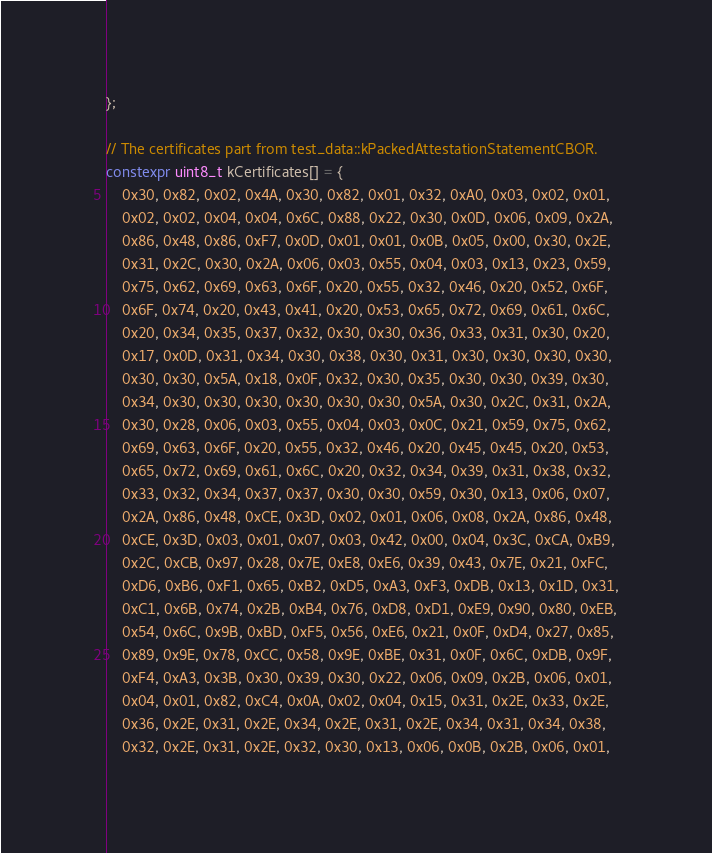Convert code to text. <code><loc_0><loc_0><loc_500><loc_500><_C++_>};

// The certificates part from test_data::kPackedAttestationStatementCBOR.
constexpr uint8_t kCertificates[] = {
    0x30, 0x82, 0x02, 0x4A, 0x30, 0x82, 0x01, 0x32, 0xA0, 0x03, 0x02, 0x01,
    0x02, 0x02, 0x04, 0x04, 0x6C, 0x88, 0x22, 0x30, 0x0D, 0x06, 0x09, 0x2A,
    0x86, 0x48, 0x86, 0xF7, 0x0D, 0x01, 0x01, 0x0B, 0x05, 0x00, 0x30, 0x2E,
    0x31, 0x2C, 0x30, 0x2A, 0x06, 0x03, 0x55, 0x04, 0x03, 0x13, 0x23, 0x59,
    0x75, 0x62, 0x69, 0x63, 0x6F, 0x20, 0x55, 0x32, 0x46, 0x20, 0x52, 0x6F,
    0x6F, 0x74, 0x20, 0x43, 0x41, 0x20, 0x53, 0x65, 0x72, 0x69, 0x61, 0x6C,
    0x20, 0x34, 0x35, 0x37, 0x32, 0x30, 0x30, 0x36, 0x33, 0x31, 0x30, 0x20,
    0x17, 0x0D, 0x31, 0x34, 0x30, 0x38, 0x30, 0x31, 0x30, 0x30, 0x30, 0x30,
    0x30, 0x30, 0x5A, 0x18, 0x0F, 0x32, 0x30, 0x35, 0x30, 0x30, 0x39, 0x30,
    0x34, 0x30, 0x30, 0x30, 0x30, 0x30, 0x30, 0x5A, 0x30, 0x2C, 0x31, 0x2A,
    0x30, 0x28, 0x06, 0x03, 0x55, 0x04, 0x03, 0x0C, 0x21, 0x59, 0x75, 0x62,
    0x69, 0x63, 0x6F, 0x20, 0x55, 0x32, 0x46, 0x20, 0x45, 0x45, 0x20, 0x53,
    0x65, 0x72, 0x69, 0x61, 0x6C, 0x20, 0x32, 0x34, 0x39, 0x31, 0x38, 0x32,
    0x33, 0x32, 0x34, 0x37, 0x37, 0x30, 0x30, 0x59, 0x30, 0x13, 0x06, 0x07,
    0x2A, 0x86, 0x48, 0xCE, 0x3D, 0x02, 0x01, 0x06, 0x08, 0x2A, 0x86, 0x48,
    0xCE, 0x3D, 0x03, 0x01, 0x07, 0x03, 0x42, 0x00, 0x04, 0x3C, 0xCA, 0xB9,
    0x2C, 0xCB, 0x97, 0x28, 0x7E, 0xE8, 0xE6, 0x39, 0x43, 0x7E, 0x21, 0xFC,
    0xD6, 0xB6, 0xF1, 0x65, 0xB2, 0xD5, 0xA3, 0xF3, 0xDB, 0x13, 0x1D, 0x31,
    0xC1, 0x6B, 0x74, 0x2B, 0xB4, 0x76, 0xD8, 0xD1, 0xE9, 0x90, 0x80, 0xEB,
    0x54, 0x6C, 0x9B, 0xBD, 0xF5, 0x56, 0xE6, 0x21, 0x0F, 0xD4, 0x27, 0x85,
    0x89, 0x9E, 0x78, 0xCC, 0x58, 0x9E, 0xBE, 0x31, 0x0F, 0x6C, 0xDB, 0x9F,
    0xF4, 0xA3, 0x3B, 0x30, 0x39, 0x30, 0x22, 0x06, 0x09, 0x2B, 0x06, 0x01,
    0x04, 0x01, 0x82, 0xC4, 0x0A, 0x02, 0x04, 0x15, 0x31, 0x2E, 0x33, 0x2E,
    0x36, 0x2E, 0x31, 0x2E, 0x34, 0x2E, 0x31, 0x2E, 0x34, 0x31, 0x34, 0x38,
    0x32, 0x2E, 0x31, 0x2E, 0x32, 0x30, 0x13, 0x06, 0x0B, 0x2B, 0x06, 0x01,</code> 